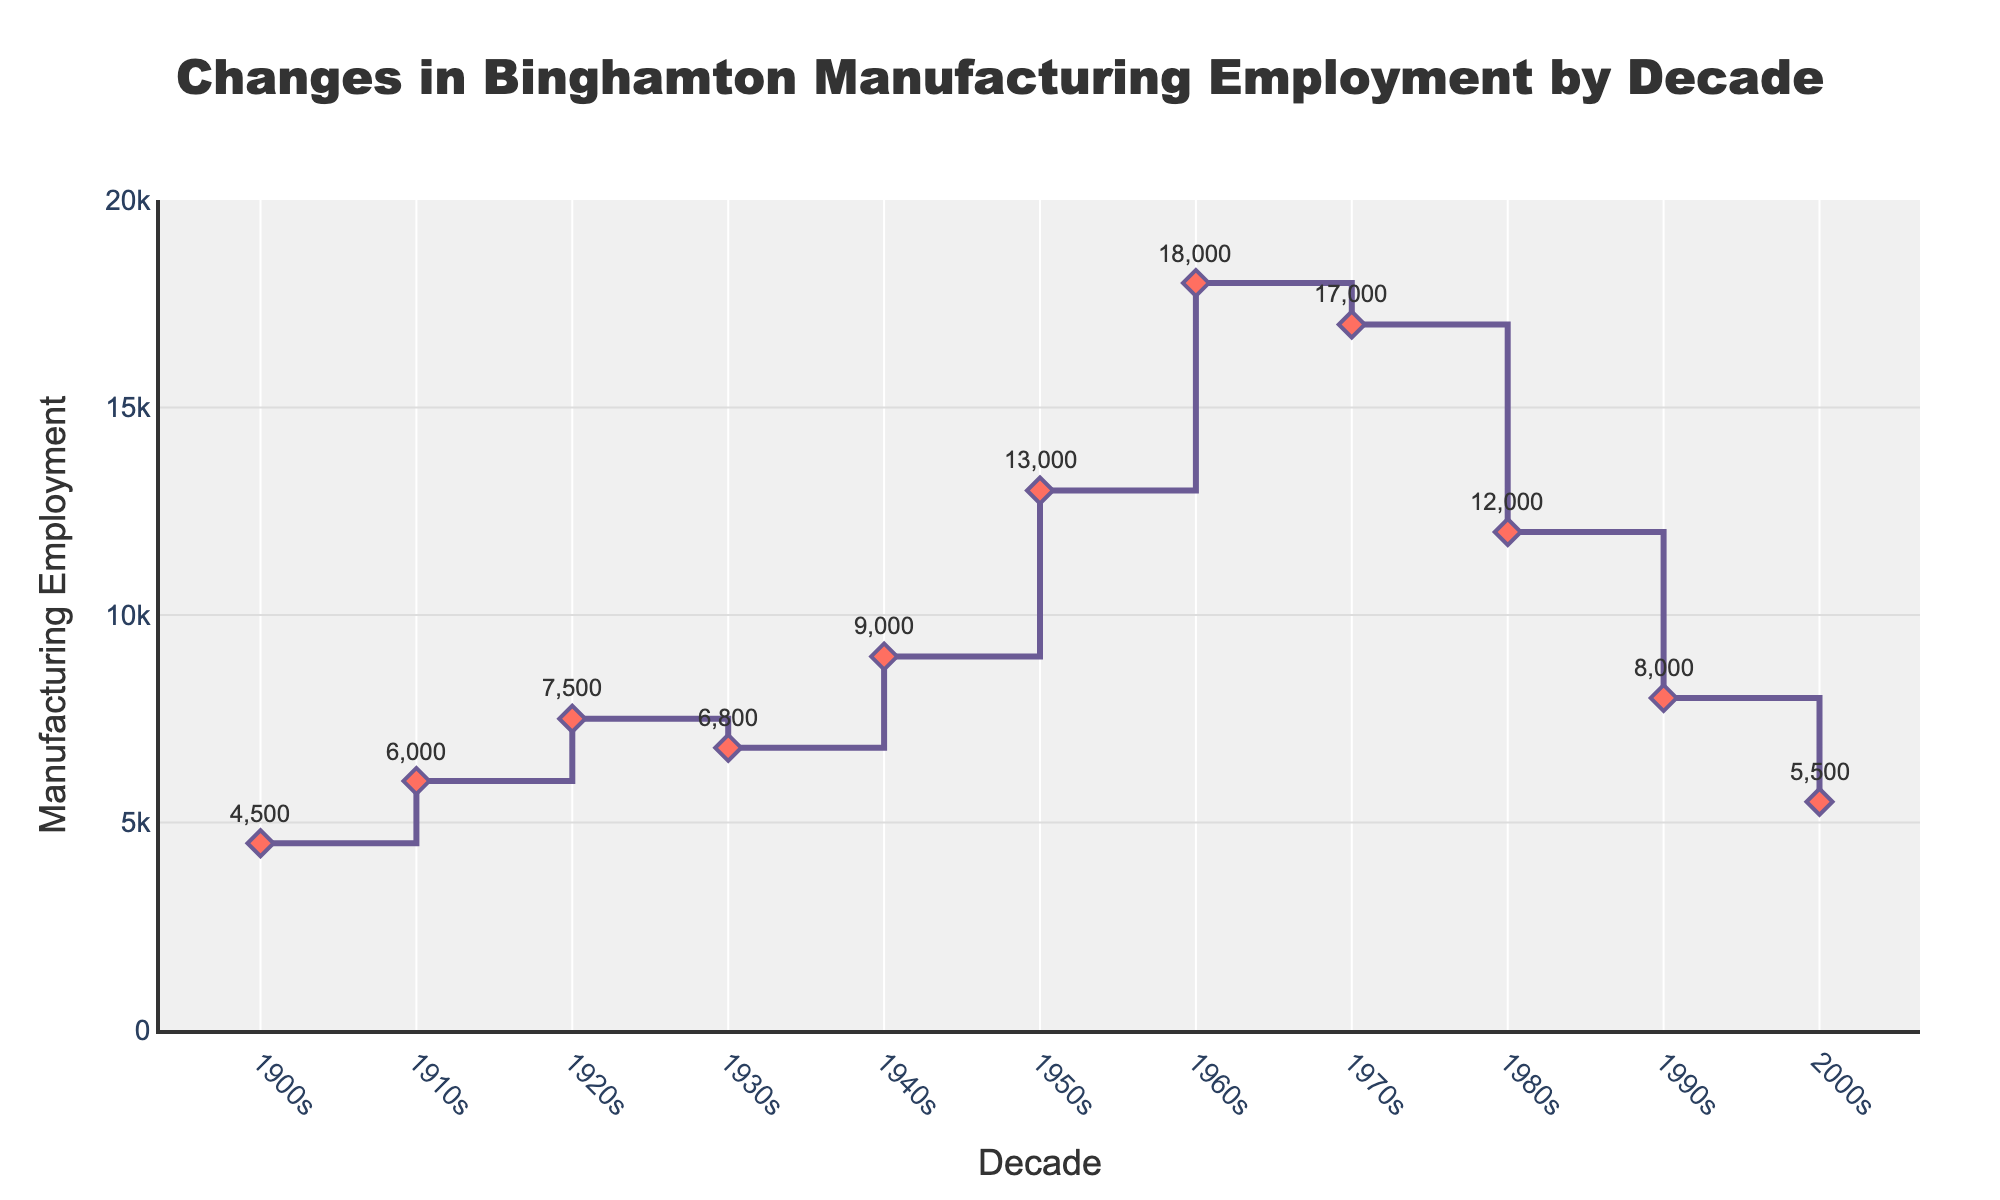What is the title of the figure? The title is prominently displayed at the top of the figure. It provides context for the data being visualized.
Answer: Changes in Binghamton Manufacturing Employment by Decade What was the manufacturing employment in the 1960s? Locate the diamond symbol at the 1960s on the x-axis, and refer to the annotated value.
Answer: 18,000 How does the manufacturing employment in the 1990s compare to the 1980s? Identify the employment values for both decades, then compare them. 1990s shows 8,000 and 1980s shows 12,000, so 1990s is lower.
Answer: Lower in the 1990s In which decade did Binghamton experience the highest manufacturing employment? Observe all the data points and identify the highest value among them. The highest employment value of 18,000 occurred in the 1960s.
Answer: 1960s What is the difference in employment between the 1950s and the 2000s? Find the values for the two decades, 13,000 in the 1950s and 5,500 in the 2000s, then subtract 5,500 from 13,000.
Answer: 7,500 Did the manufacturing employment ever decrease from one decade to the next? Examine the step-like pattern of the stair plot, noting any instances where employment decreases. Examples include the decline from the 1960s (18,000) to the 1970s (17,000).
Answer: Yes How many decades are covered by this figure? Count the number of distinct time points along the x-axis. From 1900s to 2000s, there are 11 decades.
Answer: 11 Which decade saw the largest increase in manufacturing employment? Compute the differences between sequential decades. The most significant increase is from the 1950s (13,000) to the 1960s (18,000), an increase of 5,000.
Answer: 1960s What is the trend of manufacturing employment from 1970s to 2000s? Observe the values from 1970s (17,000) to 2000s (5,500), which show a downward trend.
Answer: Decreasing What is the average manufacturing employment across all decades shown? Sum all employment values (4,500 + 6,000 + 7,500 + 6,800 + 9,000 + 13,000 + 18,000 + 17,000 + 12,000 + 8,000 + 5,500) and divide by 11. Total is 107,300, so 107,300 / 11.
Answer: 9,754 